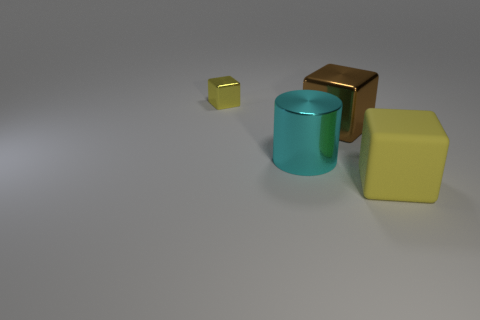Add 4 tiny brown shiny balls. How many objects exist? 8 Subtract all cubes. How many objects are left? 1 Subtract all big red shiny cylinders. Subtract all big cyan things. How many objects are left? 3 Add 2 tiny things. How many tiny things are left? 3 Add 3 small yellow metal blocks. How many small yellow metal blocks exist? 4 Subtract 0 cyan spheres. How many objects are left? 4 